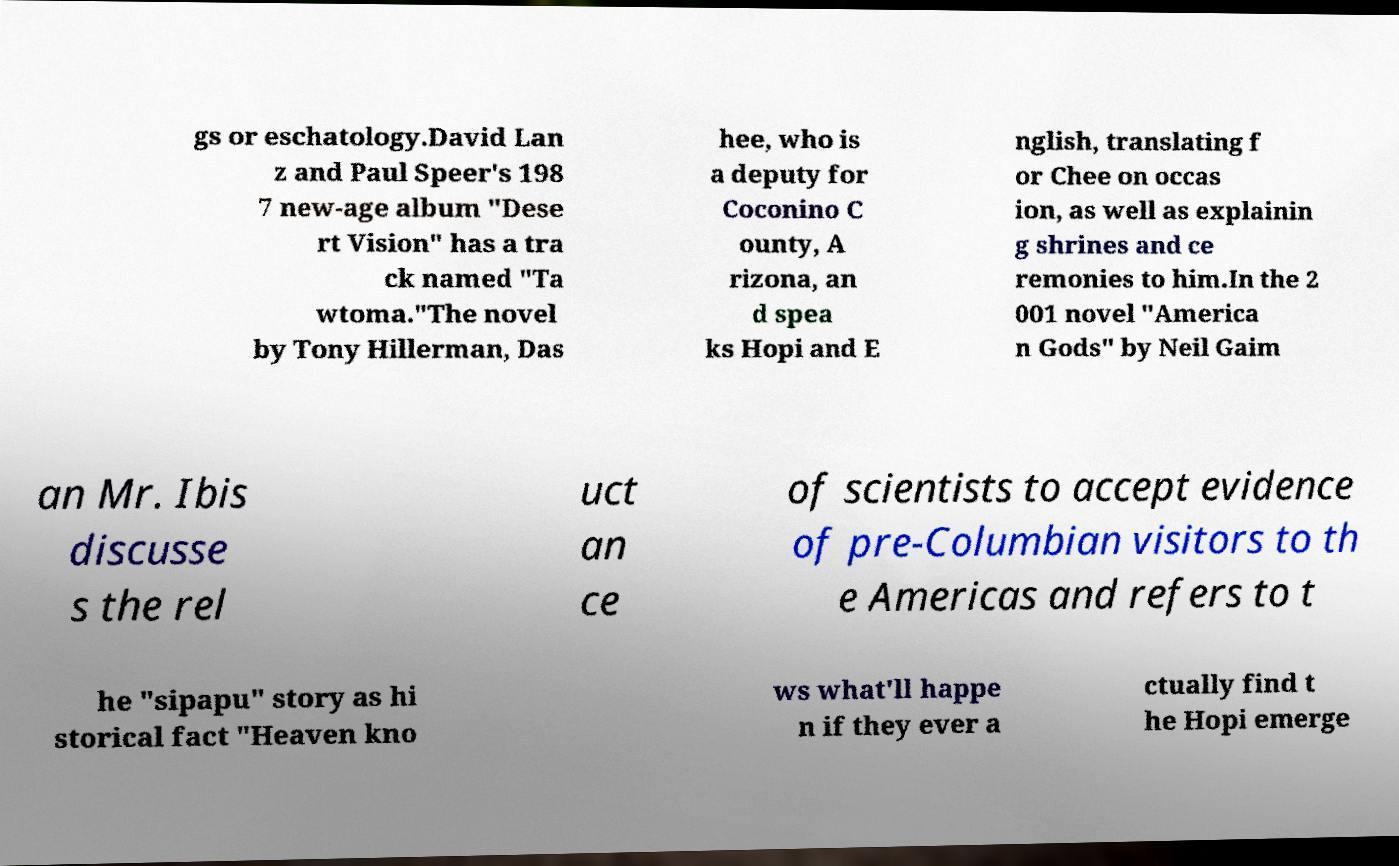There's text embedded in this image that I need extracted. Can you transcribe it verbatim? gs or eschatology.David Lan z and Paul Speer's 198 7 new-age album "Dese rt Vision" has a tra ck named "Ta wtoma."The novel by Tony Hillerman, Das hee, who is a deputy for Coconino C ounty, A rizona, an d spea ks Hopi and E nglish, translating f or Chee on occas ion, as well as explainin g shrines and ce remonies to him.In the 2 001 novel "America n Gods" by Neil Gaim an Mr. Ibis discusse s the rel uct an ce of scientists to accept evidence of pre-Columbian visitors to th e Americas and refers to t he "sipapu" story as hi storical fact "Heaven kno ws what'll happe n if they ever a ctually find t he Hopi emerge 